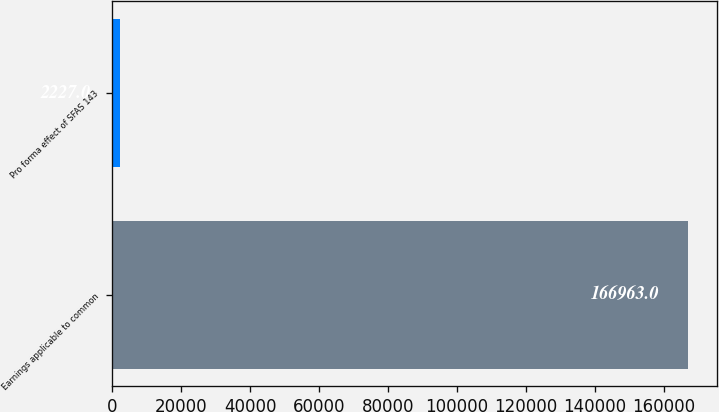Convert chart to OTSL. <chart><loc_0><loc_0><loc_500><loc_500><bar_chart><fcel>Earnings applicable to common<fcel>Pro forma effect of SFAS 143<nl><fcel>166963<fcel>2227<nl></chart> 